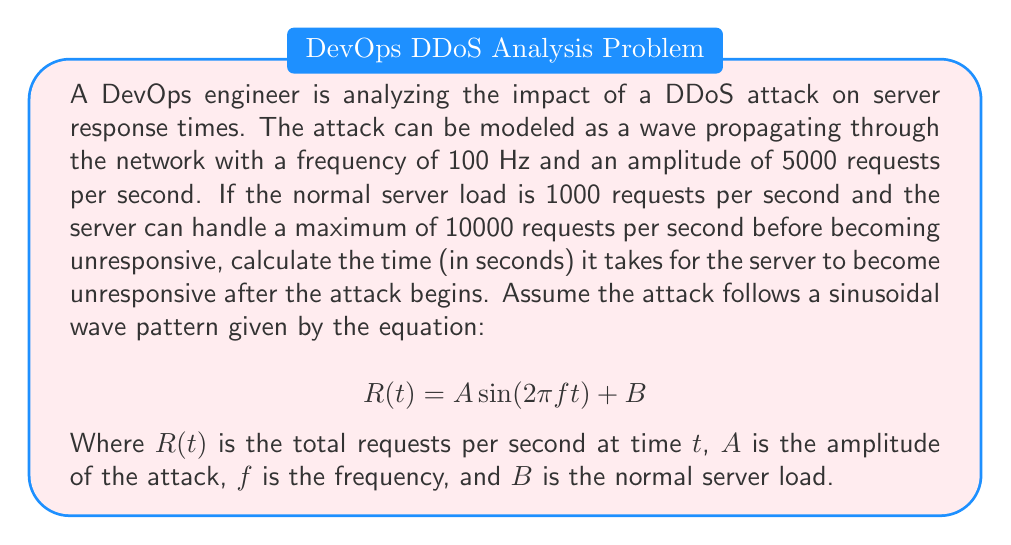Solve this math problem. To solve this problem, we'll follow these steps:

1. Identify the given parameters:
   - Frequency (f) = 100 Hz
   - Amplitude (A) = 5000 requests/second
   - Normal server load (B) = 1000 requests/second
   - Maximum server capacity = 10000 requests/second

2. Set up the equation for the total requests per second:
   $$R(t) = 5000 \sin(2\pi \cdot 100t) + 1000$$

3. To find when the server becomes unresponsive, we need to solve:
   $$10000 = 5000 \sin(2\pi \cdot 100t) + 1000$$

4. Simplify the equation:
   $$9000 = 5000 \sin(2\pi \cdot 100t)$$

5. Divide both sides by 5000:
   $$1.8 = \sin(2\pi \cdot 100t)$$

6. Apply the inverse sine function to both sides:
   $$\arcsin(1.8) = 2\pi \cdot 100t$$

7. Solve for t:
   $$t = \frac{\arcsin(1.8)}{2\pi \cdot 100}$$

8. Calculate the result:
   $$t \approx 0.00286 \text{ seconds}$$

This result indicates that the server will become unresponsive approximately 0.00286 seconds (or 2.86 milliseconds) after the attack begins.
Answer: 0.00286 seconds 